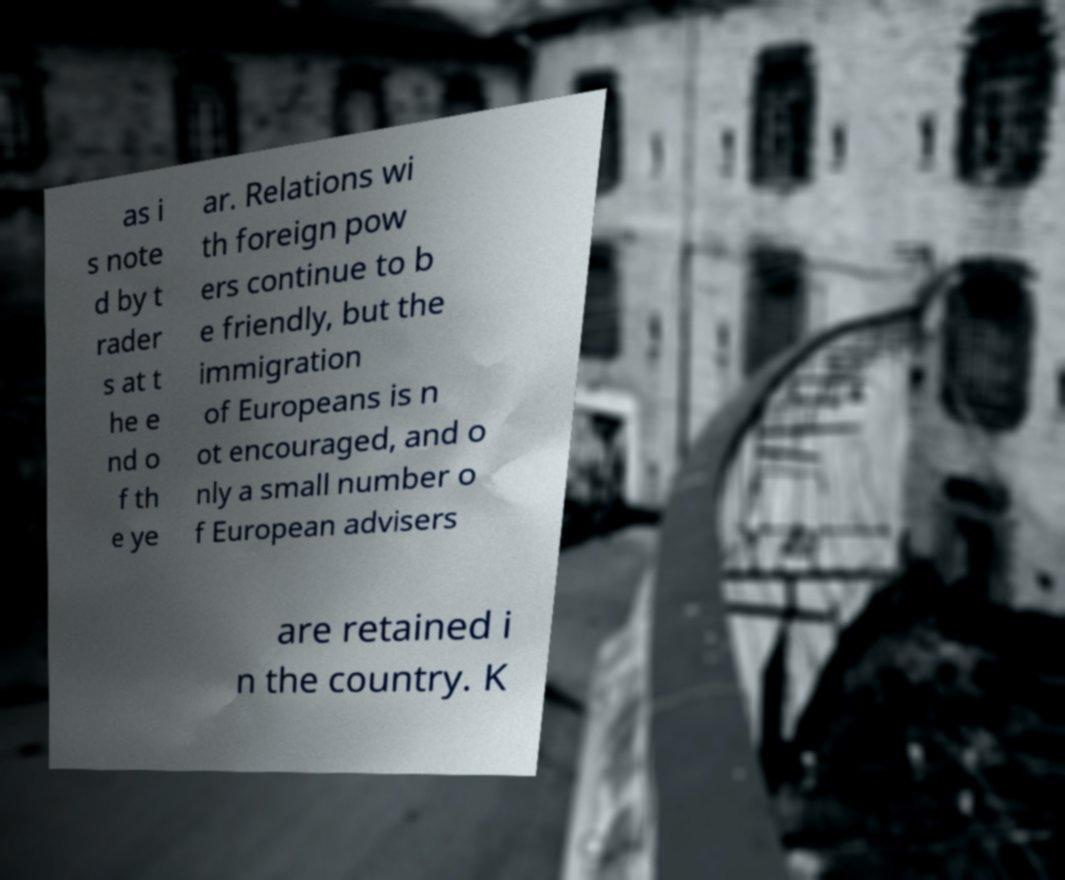Can you read and provide the text displayed in the image?This photo seems to have some interesting text. Can you extract and type it out for me? as i s note d by t rader s at t he e nd o f th e ye ar. Relations wi th foreign pow ers continue to b e friendly, but the immigration of Europeans is n ot encouraged, and o nly a small number o f European advisers are retained i n the country. K 